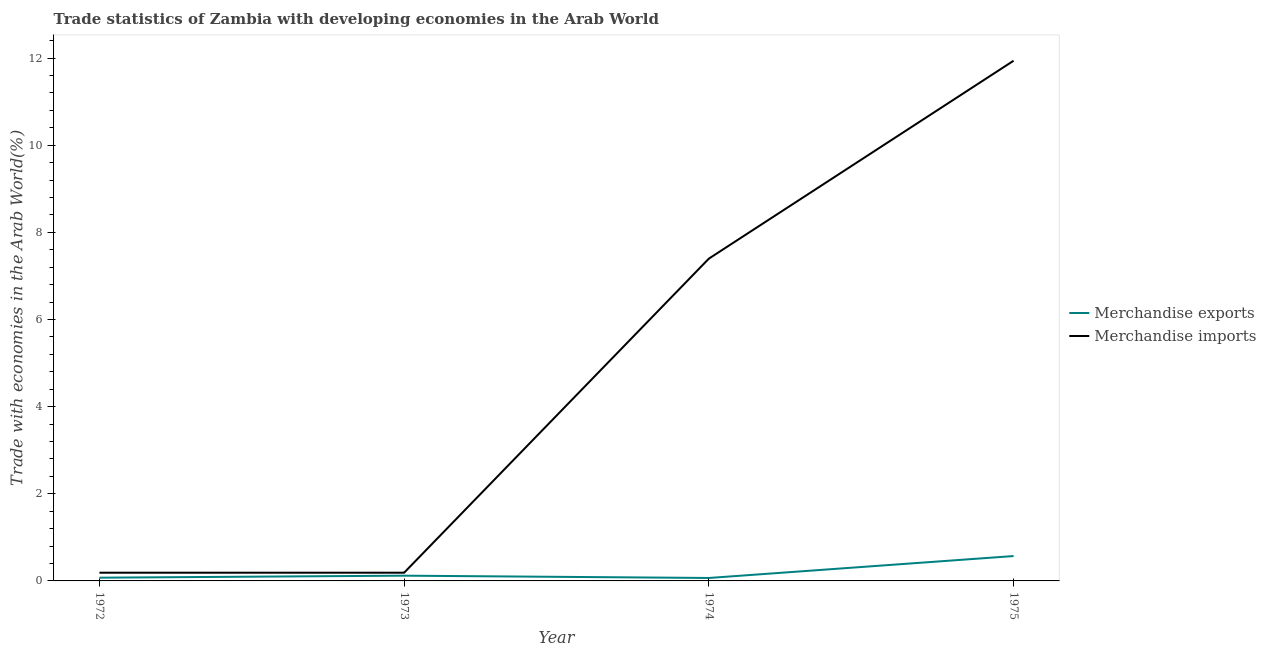Is the number of lines equal to the number of legend labels?
Offer a terse response. Yes. What is the merchandise imports in 1975?
Give a very brief answer. 11.94. Across all years, what is the maximum merchandise imports?
Offer a terse response. 11.94. Across all years, what is the minimum merchandise imports?
Offer a very short reply. 0.19. In which year was the merchandise imports maximum?
Keep it short and to the point. 1975. In which year was the merchandise exports minimum?
Your answer should be compact. 1974. What is the total merchandise exports in the graph?
Provide a succinct answer. 0.83. What is the difference between the merchandise exports in 1972 and that in 1974?
Provide a short and direct response. 0.01. What is the difference between the merchandise exports in 1975 and the merchandise imports in 1973?
Your answer should be very brief. 0.38. What is the average merchandise imports per year?
Keep it short and to the point. 4.93. In the year 1975, what is the difference between the merchandise exports and merchandise imports?
Provide a succinct answer. -11.37. What is the ratio of the merchandise imports in 1973 to that in 1975?
Make the answer very short. 0.02. Is the difference between the merchandise exports in 1973 and 1974 greater than the difference between the merchandise imports in 1973 and 1974?
Make the answer very short. Yes. What is the difference between the highest and the second highest merchandise imports?
Make the answer very short. 4.54. What is the difference between the highest and the lowest merchandise exports?
Give a very brief answer. 0.5. In how many years, is the merchandise exports greater than the average merchandise exports taken over all years?
Ensure brevity in your answer.  1. Is the merchandise imports strictly less than the merchandise exports over the years?
Ensure brevity in your answer.  No. How many lines are there?
Your response must be concise. 2. What is the difference between two consecutive major ticks on the Y-axis?
Provide a succinct answer. 2. Does the graph contain grids?
Provide a succinct answer. No. Where does the legend appear in the graph?
Offer a terse response. Center right. How many legend labels are there?
Give a very brief answer. 2. What is the title of the graph?
Provide a succinct answer. Trade statistics of Zambia with developing economies in the Arab World. What is the label or title of the Y-axis?
Ensure brevity in your answer.  Trade with economies in the Arab World(%). What is the Trade with economies in the Arab World(%) of Merchandise exports in 1972?
Make the answer very short. 0.07. What is the Trade with economies in the Arab World(%) in Merchandise imports in 1972?
Give a very brief answer. 0.19. What is the Trade with economies in the Arab World(%) of Merchandise exports in 1973?
Give a very brief answer. 0.12. What is the Trade with economies in the Arab World(%) in Merchandise imports in 1973?
Provide a short and direct response. 0.19. What is the Trade with economies in the Arab World(%) of Merchandise exports in 1974?
Offer a terse response. 0.07. What is the Trade with economies in the Arab World(%) of Merchandise imports in 1974?
Provide a succinct answer. 7.4. What is the Trade with economies in the Arab World(%) of Merchandise exports in 1975?
Your answer should be compact. 0.57. What is the Trade with economies in the Arab World(%) of Merchandise imports in 1975?
Offer a terse response. 11.94. Across all years, what is the maximum Trade with economies in the Arab World(%) in Merchandise exports?
Provide a succinct answer. 0.57. Across all years, what is the maximum Trade with economies in the Arab World(%) in Merchandise imports?
Provide a succinct answer. 11.94. Across all years, what is the minimum Trade with economies in the Arab World(%) in Merchandise exports?
Your response must be concise. 0.07. Across all years, what is the minimum Trade with economies in the Arab World(%) of Merchandise imports?
Your answer should be compact. 0.19. What is the total Trade with economies in the Arab World(%) of Merchandise exports in the graph?
Your answer should be compact. 0.83. What is the total Trade with economies in the Arab World(%) in Merchandise imports in the graph?
Offer a terse response. 19.71. What is the difference between the Trade with economies in the Arab World(%) of Merchandise exports in 1972 and that in 1973?
Provide a short and direct response. -0.05. What is the difference between the Trade with economies in the Arab World(%) in Merchandise imports in 1972 and that in 1973?
Ensure brevity in your answer.  -0. What is the difference between the Trade with economies in the Arab World(%) in Merchandise exports in 1972 and that in 1974?
Offer a terse response. 0.01. What is the difference between the Trade with economies in the Arab World(%) of Merchandise imports in 1972 and that in 1974?
Your answer should be very brief. -7.21. What is the difference between the Trade with economies in the Arab World(%) in Merchandise exports in 1972 and that in 1975?
Provide a short and direct response. -0.5. What is the difference between the Trade with economies in the Arab World(%) in Merchandise imports in 1972 and that in 1975?
Make the answer very short. -11.75. What is the difference between the Trade with economies in the Arab World(%) in Merchandise exports in 1973 and that in 1974?
Provide a succinct answer. 0.05. What is the difference between the Trade with economies in the Arab World(%) of Merchandise imports in 1973 and that in 1974?
Your answer should be very brief. -7.21. What is the difference between the Trade with economies in the Arab World(%) in Merchandise exports in 1973 and that in 1975?
Your answer should be compact. -0.45. What is the difference between the Trade with economies in the Arab World(%) in Merchandise imports in 1973 and that in 1975?
Ensure brevity in your answer.  -11.75. What is the difference between the Trade with economies in the Arab World(%) of Merchandise exports in 1974 and that in 1975?
Your answer should be compact. -0.5. What is the difference between the Trade with economies in the Arab World(%) of Merchandise imports in 1974 and that in 1975?
Ensure brevity in your answer.  -4.54. What is the difference between the Trade with economies in the Arab World(%) of Merchandise exports in 1972 and the Trade with economies in the Arab World(%) of Merchandise imports in 1973?
Offer a terse response. -0.11. What is the difference between the Trade with economies in the Arab World(%) of Merchandise exports in 1972 and the Trade with economies in the Arab World(%) of Merchandise imports in 1974?
Give a very brief answer. -7.32. What is the difference between the Trade with economies in the Arab World(%) of Merchandise exports in 1972 and the Trade with economies in the Arab World(%) of Merchandise imports in 1975?
Offer a terse response. -11.86. What is the difference between the Trade with economies in the Arab World(%) of Merchandise exports in 1973 and the Trade with economies in the Arab World(%) of Merchandise imports in 1974?
Keep it short and to the point. -7.28. What is the difference between the Trade with economies in the Arab World(%) of Merchandise exports in 1973 and the Trade with economies in the Arab World(%) of Merchandise imports in 1975?
Provide a short and direct response. -11.82. What is the difference between the Trade with economies in the Arab World(%) of Merchandise exports in 1974 and the Trade with economies in the Arab World(%) of Merchandise imports in 1975?
Your answer should be compact. -11.87. What is the average Trade with economies in the Arab World(%) of Merchandise exports per year?
Offer a very short reply. 0.21. What is the average Trade with economies in the Arab World(%) of Merchandise imports per year?
Provide a short and direct response. 4.93. In the year 1972, what is the difference between the Trade with economies in the Arab World(%) in Merchandise exports and Trade with economies in the Arab World(%) in Merchandise imports?
Your response must be concise. -0.11. In the year 1973, what is the difference between the Trade with economies in the Arab World(%) in Merchandise exports and Trade with economies in the Arab World(%) in Merchandise imports?
Your answer should be very brief. -0.07. In the year 1974, what is the difference between the Trade with economies in the Arab World(%) of Merchandise exports and Trade with economies in the Arab World(%) of Merchandise imports?
Your answer should be compact. -7.33. In the year 1975, what is the difference between the Trade with economies in the Arab World(%) in Merchandise exports and Trade with economies in the Arab World(%) in Merchandise imports?
Ensure brevity in your answer.  -11.37. What is the ratio of the Trade with economies in the Arab World(%) of Merchandise exports in 1972 to that in 1973?
Offer a terse response. 0.62. What is the ratio of the Trade with economies in the Arab World(%) of Merchandise exports in 1972 to that in 1974?
Your response must be concise. 1.1. What is the ratio of the Trade with economies in the Arab World(%) of Merchandise imports in 1972 to that in 1974?
Your answer should be compact. 0.03. What is the ratio of the Trade with economies in the Arab World(%) in Merchandise exports in 1972 to that in 1975?
Provide a short and direct response. 0.13. What is the ratio of the Trade with economies in the Arab World(%) of Merchandise imports in 1972 to that in 1975?
Keep it short and to the point. 0.02. What is the ratio of the Trade with economies in the Arab World(%) of Merchandise exports in 1973 to that in 1974?
Provide a succinct answer. 1.78. What is the ratio of the Trade with economies in the Arab World(%) of Merchandise imports in 1973 to that in 1974?
Make the answer very short. 0.03. What is the ratio of the Trade with economies in the Arab World(%) in Merchandise exports in 1973 to that in 1975?
Offer a terse response. 0.21. What is the ratio of the Trade with economies in the Arab World(%) of Merchandise imports in 1973 to that in 1975?
Give a very brief answer. 0.02. What is the ratio of the Trade with economies in the Arab World(%) in Merchandise exports in 1974 to that in 1975?
Ensure brevity in your answer.  0.12. What is the ratio of the Trade with economies in the Arab World(%) in Merchandise imports in 1974 to that in 1975?
Keep it short and to the point. 0.62. What is the difference between the highest and the second highest Trade with economies in the Arab World(%) of Merchandise exports?
Provide a succinct answer. 0.45. What is the difference between the highest and the second highest Trade with economies in the Arab World(%) in Merchandise imports?
Ensure brevity in your answer.  4.54. What is the difference between the highest and the lowest Trade with economies in the Arab World(%) of Merchandise exports?
Ensure brevity in your answer.  0.5. What is the difference between the highest and the lowest Trade with economies in the Arab World(%) of Merchandise imports?
Give a very brief answer. 11.75. 